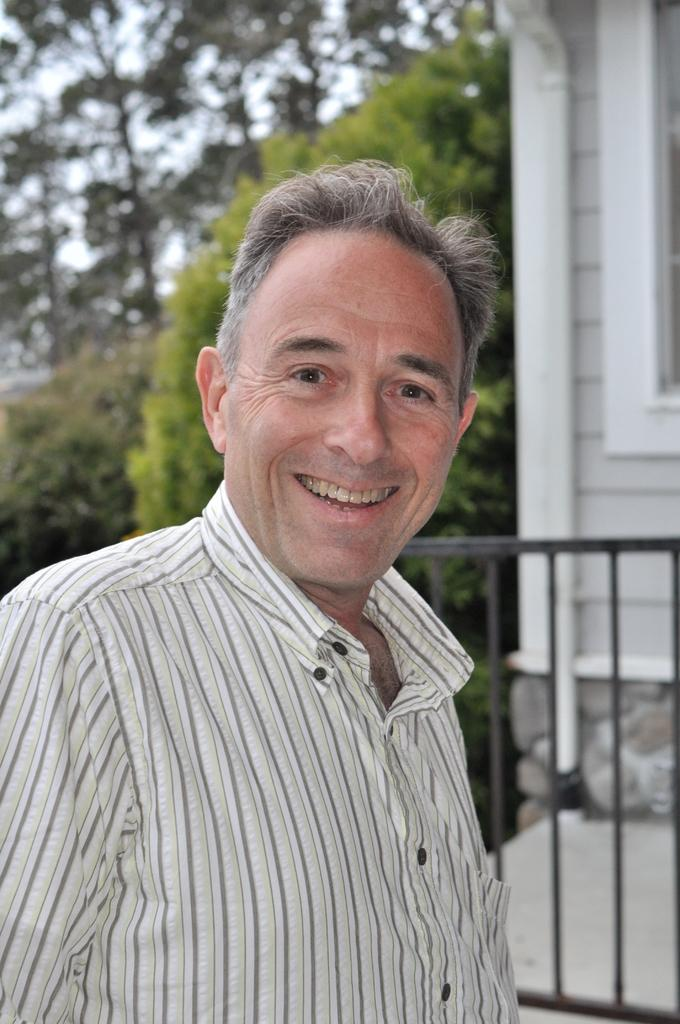Who is present in the image? There is a person in the image. What is the person doing in the image? The person is smiling. What can be seen in the right corner of the image? There is a building in the right corner of the image. What type of natural environment is visible in the background of the image? There are trees in the background of the image. Who is the owner of the shop in the image? There is no shop present in the image, so it is not possible to determine the owner. 